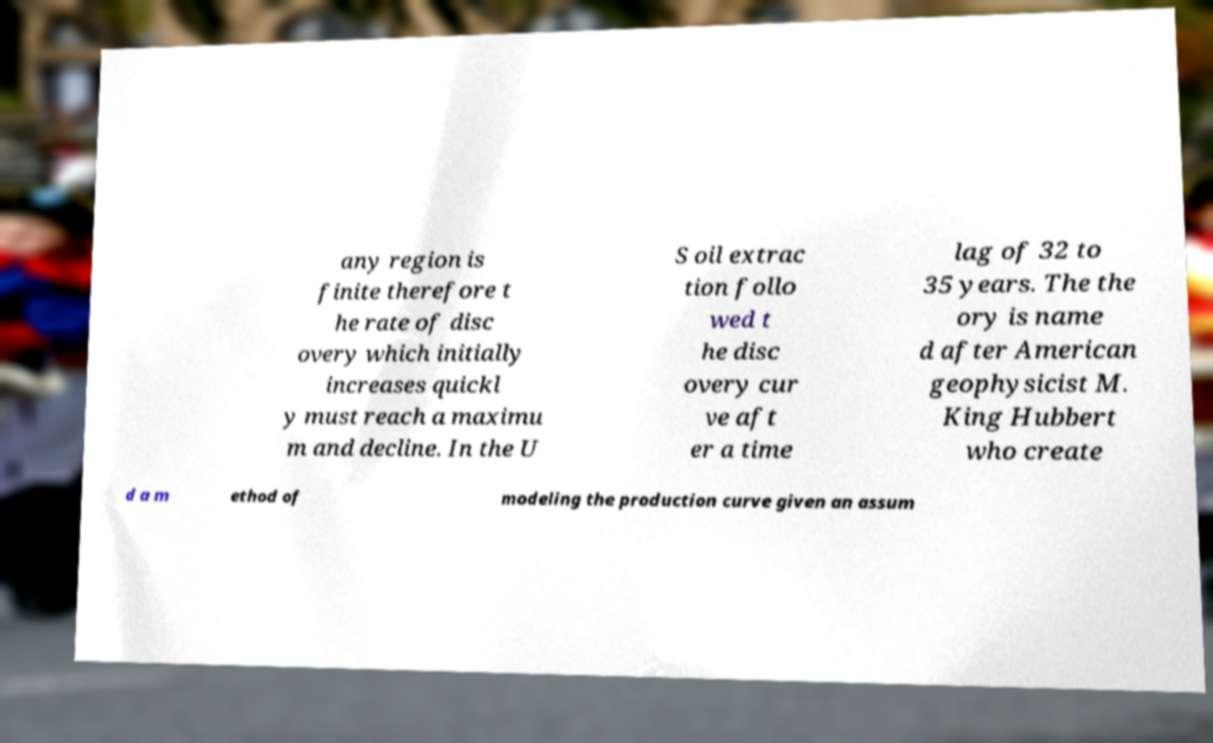Could you assist in decoding the text presented in this image and type it out clearly? any region is finite therefore t he rate of disc overy which initially increases quickl y must reach a maximu m and decline. In the U S oil extrac tion follo wed t he disc overy cur ve aft er a time lag of 32 to 35 years. The the ory is name d after American geophysicist M. King Hubbert who create d a m ethod of modeling the production curve given an assum 